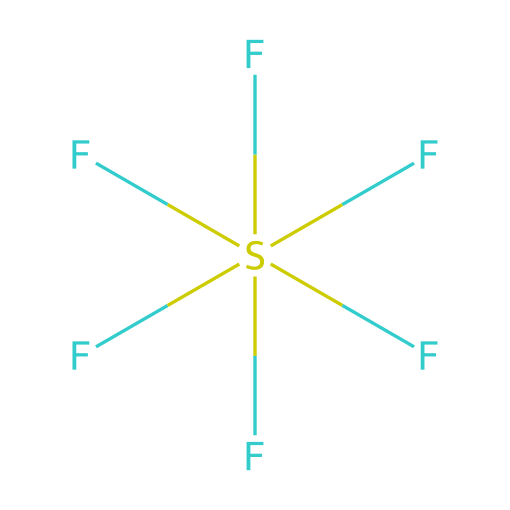What is the central atom in this molecule? The central atom in the structure can be identified as sulfur, which is denoted by the "S" in the SMILES representation. This indicates it is the central atom surrounded by fluorine atoms.
Answer: sulfur How many fluorine atoms are bonded to the central atom? By examining the SMILES, there are six fluorine atoms indicated by the letter "F" and their connections to the central sulfur atom "S". Each designation of "(F)" implies an individual bond to the sulfur.
Answer: six What is the hybridization of the sulfur atom in this compound? The sulfur atom is bonded to six fluorine atoms, suggesting it uses six orbitals. This corresponds to an octahedral geometry, indicating that the hybridization is sp3d2.
Answer: sp3d2 Is sulfur hexafluoride a polar or nonpolar molecule? The symmetry of the molecule with six identical fluorine atoms surrounding the sulfur leads to a cancellation of dipole moments, categorizing it as a nonpolar molecule.
Answer: nonpolar What type of bonding exists between sulfur and fluorine in this compound? Given that sulfur and fluorine have significant electronegativity differences, they form polar covalent bonds. However, the dominance of fluorine in terms of electronegativity leads to the bonds being polar covalent in nature.
Answer: polar covalent Does sulfur hexafluoride exhibit hypervalency? Yes, sulfur hexafluoride displays hypervalency since sulfur can accommodate more than four bonds due to its ability to expand its valence shell, resulting in six bonds to fluorine.
Answer: yes 